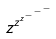Convert formula to latex. <formula><loc_0><loc_0><loc_500><loc_500>z ^ { z ^ { z ^ { - ^ { - ^ { - } } } } }</formula> 